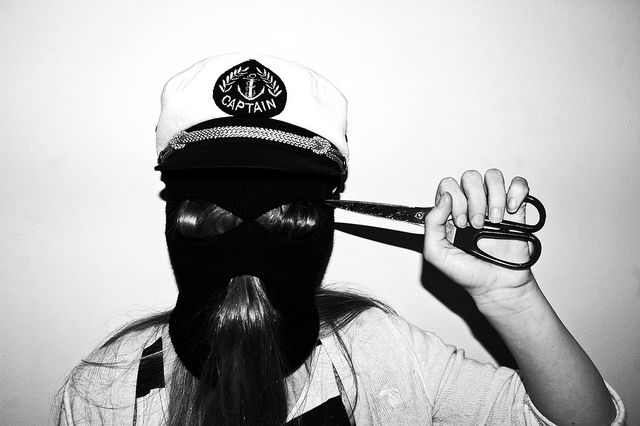Extract all visible text content from this image. CAPTAIN 